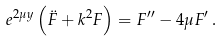<formula> <loc_0><loc_0><loc_500><loc_500>e ^ { 2 \mu y } \left ( \ddot { F } + k ^ { 2 } F \right ) = F ^ { \prime \prime } - 4 \mu F ^ { \prime } \, .</formula> 